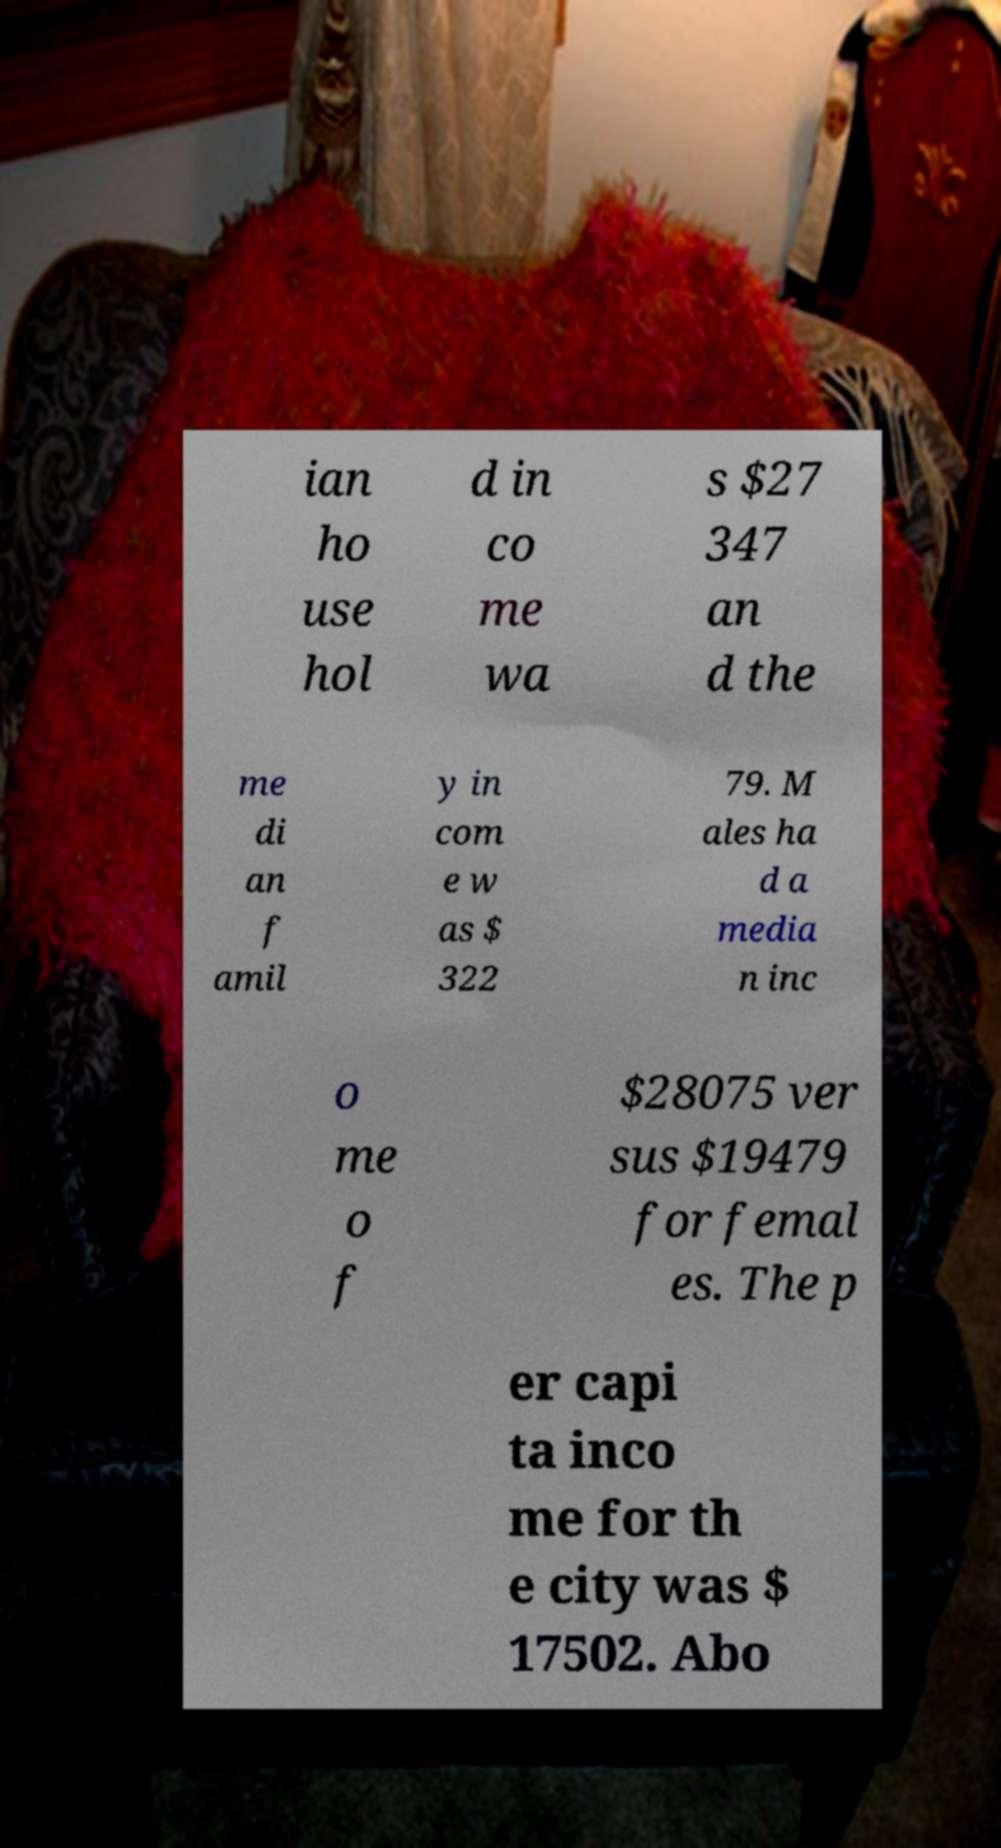Please read and relay the text visible in this image. What does it say? ian ho use hol d in co me wa s $27 347 an d the me di an f amil y in com e w as $ 322 79. M ales ha d a media n inc o me o f $28075 ver sus $19479 for femal es. The p er capi ta inco me for th e city was $ 17502. Abo 